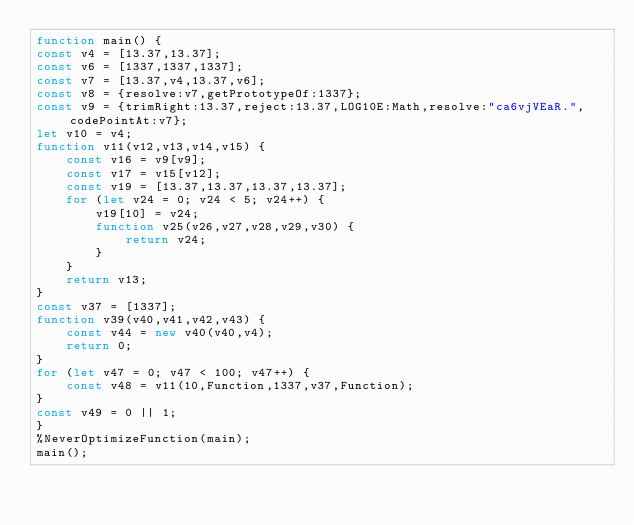<code> <loc_0><loc_0><loc_500><loc_500><_JavaScript_>function main() {
const v4 = [13.37,13.37];
const v6 = [1337,1337,1337];
const v7 = [13.37,v4,13.37,v6];
const v8 = {resolve:v7,getPrototypeOf:1337};
const v9 = {trimRight:13.37,reject:13.37,LOG10E:Math,resolve:"ca6vjVEaR.",codePointAt:v7};
let v10 = v4;
function v11(v12,v13,v14,v15) {
    const v16 = v9[v9];
    const v17 = v15[v12];
    const v19 = [13.37,13.37,13.37,13.37];
    for (let v24 = 0; v24 < 5; v24++) {
        v19[10] = v24;
        function v25(v26,v27,v28,v29,v30) {
            return v24;
        }
    }
    return v13;
}
const v37 = [1337];
function v39(v40,v41,v42,v43) {
    const v44 = new v40(v40,v4);
    return 0;
}
for (let v47 = 0; v47 < 100; v47++) {
    const v48 = v11(10,Function,1337,v37,Function);
}
const v49 = 0 || 1;
}
%NeverOptimizeFunction(main);
main();
</code> 